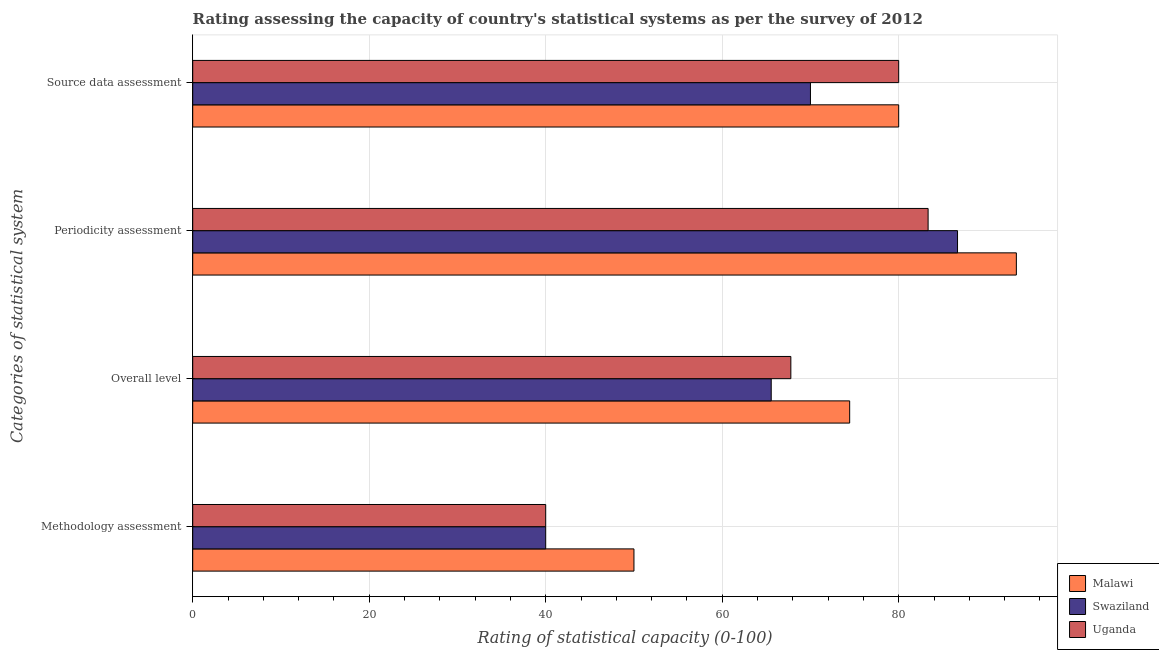How many groups of bars are there?
Provide a succinct answer. 4. What is the label of the 4th group of bars from the top?
Give a very brief answer. Methodology assessment. What is the periodicity assessment rating in Malawi?
Offer a very short reply. 93.33. Across all countries, what is the maximum source data assessment rating?
Provide a short and direct response. 80. Across all countries, what is the minimum periodicity assessment rating?
Your answer should be compact. 83.33. In which country was the periodicity assessment rating maximum?
Your answer should be very brief. Malawi. In which country was the methodology assessment rating minimum?
Your answer should be compact. Swaziland. What is the total overall level rating in the graph?
Offer a terse response. 207.78. What is the difference between the overall level rating in Uganda and that in Swaziland?
Provide a succinct answer. 2.22. What is the difference between the overall level rating in Swaziland and the periodicity assessment rating in Uganda?
Make the answer very short. -17.78. What is the average periodicity assessment rating per country?
Make the answer very short. 87.78. In how many countries, is the overall level rating greater than 52 ?
Ensure brevity in your answer.  3. What is the ratio of the overall level rating in Uganda to that in Swaziland?
Offer a very short reply. 1.03. Is the methodology assessment rating in Malawi less than that in Swaziland?
Provide a succinct answer. No. Is the difference between the overall level rating in Swaziland and Uganda greater than the difference between the periodicity assessment rating in Swaziland and Uganda?
Ensure brevity in your answer.  No. What is the difference between the highest and the second highest source data assessment rating?
Offer a very short reply. 0. What is the difference between the highest and the lowest periodicity assessment rating?
Give a very brief answer. 10. In how many countries, is the methodology assessment rating greater than the average methodology assessment rating taken over all countries?
Make the answer very short. 1. Is it the case that in every country, the sum of the overall level rating and source data assessment rating is greater than the sum of methodology assessment rating and periodicity assessment rating?
Ensure brevity in your answer.  No. What does the 1st bar from the top in Methodology assessment represents?
Ensure brevity in your answer.  Uganda. What does the 2nd bar from the bottom in Methodology assessment represents?
Keep it short and to the point. Swaziland. Is it the case that in every country, the sum of the methodology assessment rating and overall level rating is greater than the periodicity assessment rating?
Your response must be concise. Yes. How many countries are there in the graph?
Offer a terse response. 3. What is the difference between two consecutive major ticks on the X-axis?
Offer a terse response. 20. Where does the legend appear in the graph?
Give a very brief answer. Bottom right. How many legend labels are there?
Make the answer very short. 3. How are the legend labels stacked?
Provide a short and direct response. Vertical. What is the title of the graph?
Offer a very short reply. Rating assessing the capacity of country's statistical systems as per the survey of 2012 . What is the label or title of the X-axis?
Your answer should be compact. Rating of statistical capacity (0-100). What is the label or title of the Y-axis?
Your answer should be very brief. Categories of statistical system. What is the Rating of statistical capacity (0-100) of Swaziland in Methodology assessment?
Your answer should be compact. 40. What is the Rating of statistical capacity (0-100) of Uganda in Methodology assessment?
Your response must be concise. 40. What is the Rating of statistical capacity (0-100) of Malawi in Overall level?
Your response must be concise. 74.44. What is the Rating of statistical capacity (0-100) in Swaziland in Overall level?
Offer a very short reply. 65.56. What is the Rating of statistical capacity (0-100) in Uganda in Overall level?
Provide a short and direct response. 67.78. What is the Rating of statistical capacity (0-100) in Malawi in Periodicity assessment?
Ensure brevity in your answer.  93.33. What is the Rating of statistical capacity (0-100) in Swaziland in Periodicity assessment?
Offer a very short reply. 86.67. What is the Rating of statistical capacity (0-100) in Uganda in Periodicity assessment?
Offer a terse response. 83.33. What is the Rating of statistical capacity (0-100) in Malawi in Source data assessment?
Offer a very short reply. 80. What is the Rating of statistical capacity (0-100) of Swaziland in Source data assessment?
Give a very brief answer. 70. Across all Categories of statistical system, what is the maximum Rating of statistical capacity (0-100) of Malawi?
Give a very brief answer. 93.33. Across all Categories of statistical system, what is the maximum Rating of statistical capacity (0-100) in Swaziland?
Keep it short and to the point. 86.67. Across all Categories of statistical system, what is the maximum Rating of statistical capacity (0-100) in Uganda?
Your answer should be compact. 83.33. Across all Categories of statistical system, what is the minimum Rating of statistical capacity (0-100) in Malawi?
Offer a very short reply. 50. Across all Categories of statistical system, what is the minimum Rating of statistical capacity (0-100) of Swaziland?
Your response must be concise. 40. What is the total Rating of statistical capacity (0-100) of Malawi in the graph?
Give a very brief answer. 297.78. What is the total Rating of statistical capacity (0-100) in Swaziland in the graph?
Keep it short and to the point. 262.22. What is the total Rating of statistical capacity (0-100) of Uganda in the graph?
Ensure brevity in your answer.  271.11. What is the difference between the Rating of statistical capacity (0-100) in Malawi in Methodology assessment and that in Overall level?
Offer a terse response. -24.44. What is the difference between the Rating of statistical capacity (0-100) of Swaziland in Methodology assessment and that in Overall level?
Offer a terse response. -25.56. What is the difference between the Rating of statistical capacity (0-100) of Uganda in Methodology assessment and that in Overall level?
Ensure brevity in your answer.  -27.78. What is the difference between the Rating of statistical capacity (0-100) in Malawi in Methodology assessment and that in Periodicity assessment?
Make the answer very short. -43.33. What is the difference between the Rating of statistical capacity (0-100) of Swaziland in Methodology assessment and that in Periodicity assessment?
Offer a very short reply. -46.67. What is the difference between the Rating of statistical capacity (0-100) in Uganda in Methodology assessment and that in Periodicity assessment?
Offer a very short reply. -43.33. What is the difference between the Rating of statistical capacity (0-100) in Uganda in Methodology assessment and that in Source data assessment?
Offer a very short reply. -40. What is the difference between the Rating of statistical capacity (0-100) in Malawi in Overall level and that in Periodicity assessment?
Offer a very short reply. -18.89. What is the difference between the Rating of statistical capacity (0-100) of Swaziland in Overall level and that in Periodicity assessment?
Your answer should be compact. -21.11. What is the difference between the Rating of statistical capacity (0-100) of Uganda in Overall level and that in Periodicity assessment?
Keep it short and to the point. -15.56. What is the difference between the Rating of statistical capacity (0-100) of Malawi in Overall level and that in Source data assessment?
Offer a terse response. -5.56. What is the difference between the Rating of statistical capacity (0-100) in Swaziland in Overall level and that in Source data assessment?
Ensure brevity in your answer.  -4.44. What is the difference between the Rating of statistical capacity (0-100) of Uganda in Overall level and that in Source data assessment?
Your answer should be compact. -12.22. What is the difference between the Rating of statistical capacity (0-100) in Malawi in Periodicity assessment and that in Source data assessment?
Provide a short and direct response. 13.33. What is the difference between the Rating of statistical capacity (0-100) in Swaziland in Periodicity assessment and that in Source data assessment?
Offer a very short reply. 16.67. What is the difference between the Rating of statistical capacity (0-100) in Uganda in Periodicity assessment and that in Source data assessment?
Ensure brevity in your answer.  3.33. What is the difference between the Rating of statistical capacity (0-100) in Malawi in Methodology assessment and the Rating of statistical capacity (0-100) in Swaziland in Overall level?
Your response must be concise. -15.56. What is the difference between the Rating of statistical capacity (0-100) in Malawi in Methodology assessment and the Rating of statistical capacity (0-100) in Uganda in Overall level?
Offer a very short reply. -17.78. What is the difference between the Rating of statistical capacity (0-100) of Swaziland in Methodology assessment and the Rating of statistical capacity (0-100) of Uganda in Overall level?
Offer a very short reply. -27.78. What is the difference between the Rating of statistical capacity (0-100) of Malawi in Methodology assessment and the Rating of statistical capacity (0-100) of Swaziland in Periodicity assessment?
Your answer should be compact. -36.67. What is the difference between the Rating of statistical capacity (0-100) of Malawi in Methodology assessment and the Rating of statistical capacity (0-100) of Uganda in Periodicity assessment?
Your response must be concise. -33.33. What is the difference between the Rating of statistical capacity (0-100) of Swaziland in Methodology assessment and the Rating of statistical capacity (0-100) of Uganda in Periodicity assessment?
Your answer should be compact. -43.33. What is the difference between the Rating of statistical capacity (0-100) of Swaziland in Methodology assessment and the Rating of statistical capacity (0-100) of Uganda in Source data assessment?
Keep it short and to the point. -40. What is the difference between the Rating of statistical capacity (0-100) in Malawi in Overall level and the Rating of statistical capacity (0-100) in Swaziland in Periodicity assessment?
Provide a succinct answer. -12.22. What is the difference between the Rating of statistical capacity (0-100) of Malawi in Overall level and the Rating of statistical capacity (0-100) of Uganda in Periodicity assessment?
Make the answer very short. -8.89. What is the difference between the Rating of statistical capacity (0-100) of Swaziland in Overall level and the Rating of statistical capacity (0-100) of Uganda in Periodicity assessment?
Your answer should be compact. -17.78. What is the difference between the Rating of statistical capacity (0-100) in Malawi in Overall level and the Rating of statistical capacity (0-100) in Swaziland in Source data assessment?
Give a very brief answer. 4.44. What is the difference between the Rating of statistical capacity (0-100) in Malawi in Overall level and the Rating of statistical capacity (0-100) in Uganda in Source data assessment?
Keep it short and to the point. -5.56. What is the difference between the Rating of statistical capacity (0-100) of Swaziland in Overall level and the Rating of statistical capacity (0-100) of Uganda in Source data assessment?
Ensure brevity in your answer.  -14.44. What is the difference between the Rating of statistical capacity (0-100) of Malawi in Periodicity assessment and the Rating of statistical capacity (0-100) of Swaziland in Source data assessment?
Ensure brevity in your answer.  23.33. What is the difference between the Rating of statistical capacity (0-100) of Malawi in Periodicity assessment and the Rating of statistical capacity (0-100) of Uganda in Source data assessment?
Provide a short and direct response. 13.33. What is the average Rating of statistical capacity (0-100) in Malawi per Categories of statistical system?
Your answer should be compact. 74.44. What is the average Rating of statistical capacity (0-100) in Swaziland per Categories of statistical system?
Give a very brief answer. 65.56. What is the average Rating of statistical capacity (0-100) in Uganda per Categories of statistical system?
Provide a short and direct response. 67.78. What is the difference between the Rating of statistical capacity (0-100) in Swaziland and Rating of statistical capacity (0-100) in Uganda in Methodology assessment?
Offer a terse response. 0. What is the difference between the Rating of statistical capacity (0-100) of Malawi and Rating of statistical capacity (0-100) of Swaziland in Overall level?
Provide a short and direct response. 8.89. What is the difference between the Rating of statistical capacity (0-100) of Malawi and Rating of statistical capacity (0-100) of Uganda in Overall level?
Provide a succinct answer. 6.67. What is the difference between the Rating of statistical capacity (0-100) in Swaziland and Rating of statistical capacity (0-100) in Uganda in Overall level?
Provide a short and direct response. -2.22. What is the difference between the Rating of statistical capacity (0-100) in Malawi and Rating of statistical capacity (0-100) in Swaziland in Periodicity assessment?
Offer a terse response. 6.67. What is the difference between the Rating of statistical capacity (0-100) in Swaziland and Rating of statistical capacity (0-100) in Uganda in Periodicity assessment?
Your answer should be very brief. 3.33. What is the difference between the Rating of statistical capacity (0-100) of Malawi and Rating of statistical capacity (0-100) of Swaziland in Source data assessment?
Your answer should be very brief. 10. What is the difference between the Rating of statistical capacity (0-100) of Malawi and Rating of statistical capacity (0-100) of Uganda in Source data assessment?
Your answer should be very brief. 0. What is the ratio of the Rating of statistical capacity (0-100) in Malawi in Methodology assessment to that in Overall level?
Your response must be concise. 0.67. What is the ratio of the Rating of statistical capacity (0-100) of Swaziland in Methodology assessment to that in Overall level?
Your answer should be compact. 0.61. What is the ratio of the Rating of statistical capacity (0-100) of Uganda in Methodology assessment to that in Overall level?
Provide a succinct answer. 0.59. What is the ratio of the Rating of statistical capacity (0-100) in Malawi in Methodology assessment to that in Periodicity assessment?
Ensure brevity in your answer.  0.54. What is the ratio of the Rating of statistical capacity (0-100) of Swaziland in Methodology assessment to that in Periodicity assessment?
Give a very brief answer. 0.46. What is the ratio of the Rating of statistical capacity (0-100) in Uganda in Methodology assessment to that in Periodicity assessment?
Ensure brevity in your answer.  0.48. What is the ratio of the Rating of statistical capacity (0-100) of Malawi in Methodology assessment to that in Source data assessment?
Your answer should be compact. 0.62. What is the ratio of the Rating of statistical capacity (0-100) in Swaziland in Methodology assessment to that in Source data assessment?
Offer a terse response. 0.57. What is the ratio of the Rating of statistical capacity (0-100) of Malawi in Overall level to that in Periodicity assessment?
Your response must be concise. 0.8. What is the ratio of the Rating of statistical capacity (0-100) in Swaziland in Overall level to that in Periodicity assessment?
Your answer should be compact. 0.76. What is the ratio of the Rating of statistical capacity (0-100) of Uganda in Overall level to that in Periodicity assessment?
Your answer should be compact. 0.81. What is the ratio of the Rating of statistical capacity (0-100) of Malawi in Overall level to that in Source data assessment?
Provide a short and direct response. 0.93. What is the ratio of the Rating of statistical capacity (0-100) of Swaziland in Overall level to that in Source data assessment?
Your answer should be compact. 0.94. What is the ratio of the Rating of statistical capacity (0-100) in Uganda in Overall level to that in Source data assessment?
Provide a short and direct response. 0.85. What is the ratio of the Rating of statistical capacity (0-100) in Malawi in Periodicity assessment to that in Source data assessment?
Keep it short and to the point. 1.17. What is the ratio of the Rating of statistical capacity (0-100) in Swaziland in Periodicity assessment to that in Source data assessment?
Your answer should be compact. 1.24. What is the ratio of the Rating of statistical capacity (0-100) in Uganda in Periodicity assessment to that in Source data assessment?
Your answer should be compact. 1.04. What is the difference between the highest and the second highest Rating of statistical capacity (0-100) of Malawi?
Offer a terse response. 13.33. What is the difference between the highest and the second highest Rating of statistical capacity (0-100) of Swaziland?
Provide a succinct answer. 16.67. What is the difference between the highest and the lowest Rating of statistical capacity (0-100) of Malawi?
Offer a terse response. 43.33. What is the difference between the highest and the lowest Rating of statistical capacity (0-100) of Swaziland?
Ensure brevity in your answer.  46.67. What is the difference between the highest and the lowest Rating of statistical capacity (0-100) in Uganda?
Your response must be concise. 43.33. 